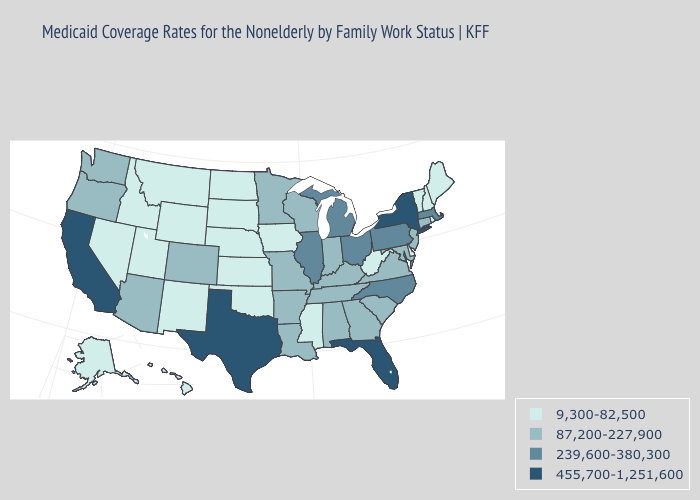What is the highest value in states that border Connecticut?
Give a very brief answer. 455,700-1,251,600. Does Mississippi have a lower value than Illinois?
Write a very short answer. Yes. Name the states that have a value in the range 9,300-82,500?
Answer briefly. Alaska, Delaware, Hawaii, Idaho, Iowa, Kansas, Maine, Mississippi, Montana, Nebraska, Nevada, New Hampshire, New Mexico, North Dakota, Oklahoma, Rhode Island, South Dakota, Utah, Vermont, West Virginia, Wyoming. Name the states that have a value in the range 9,300-82,500?
Write a very short answer. Alaska, Delaware, Hawaii, Idaho, Iowa, Kansas, Maine, Mississippi, Montana, Nebraska, Nevada, New Hampshire, New Mexico, North Dakota, Oklahoma, Rhode Island, South Dakota, Utah, Vermont, West Virginia, Wyoming. Among the states that border Iowa , which have the lowest value?
Give a very brief answer. Nebraska, South Dakota. Among the states that border Ohio , which have the lowest value?
Answer briefly. West Virginia. What is the lowest value in the MidWest?
Write a very short answer. 9,300-82,500. What is the lowest value in the MidWest?
Write a very short answer. 9,300-82,500. Name the states that have a value in the range 87,200-227,900?
Answer briefly. Alabama, Arizona, Arkansas, Colorado, Connecticut, Georgia, Indiana, Kentucky, Louisiana, Maryland, Minnesota, Missouri, New Jersey, Oregon, South Carolina, Tennessee, Virginia, Washington, Wisconsin. Does the first symbol in the legend represent the smallest category?
Keep it brief. Yes. What is the value of Nevada?
Write a very short answer. 9,300-82,500. Is the legend a continuous bar?
Short answer required. No. Which states have the lowest value in the South?
Give a very brief answer. Delaware, Mississippi, Oklahoma, West Virginia. Among the states that border Louisiana , does Mississippi have the highest value?
Keep it brief. No. Which states have the lowest value in the MidWest?
Quick response, please. Iowa, Kansas, Nebraska, North Dakota, South Dakota. 